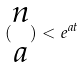Convert formula to latex. <formula><loc_0><loc_0><loc_500><loc_500>( \begin{matrix} n \\ a \end{matrix} ) < e ^ { a t }</formula> 